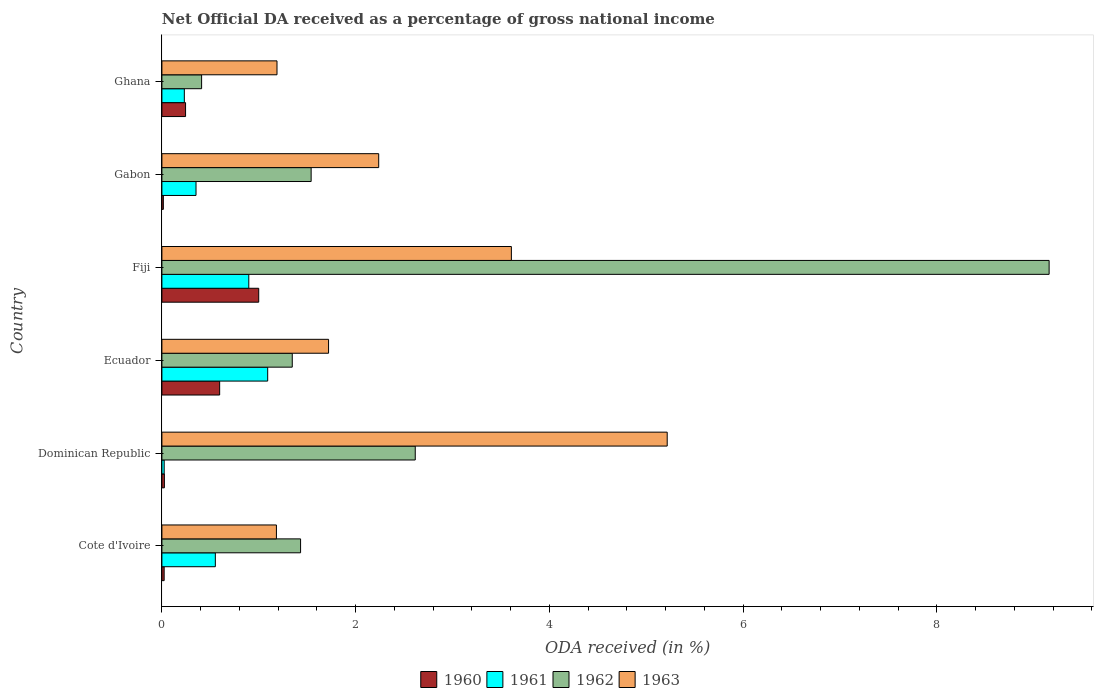How many different coloured bars are there?
Ensure brevity in your answer.  4. Are the number of bars per tick equal to the number of legend labels?
Your response must be concise. Yes. Are the number of bars on each tick of the Y-axis equal?
Keep it short and to the point. Yes. How many bars are there on the 5th tick from the top?
Provide a succinct answer. 4. What is the label of the 3rd group of bars from the top?
Provide a succinct answer. Fiji. In how many cases, is the number of bars for a given country not equal to the number of legend labels?
Offer a terse response. 0. What is the net official DA received in 1960 in Fiji?
Provide a short and direct response. 1. Across all countries, what is the maximum net official DA received in 1960?
Offer a terse response. 1. Across all countries, what is the minimum net official DA received in 1962?
Give a very brief answer. 0.41. In which country was the net official DA received in 1960 maximum?
Give a very brief answer. Fiji. In which country was the net official DA received in 1962 minimum?
Offer a terse response. Ghana. What is the total net official DA received in 1961 in the graph?
Offer a terse response. 3.15. What is the difference between the net official DA received in 1962 in Cote d'Ivoire and that in Ghana?
Give a very brief answer. 1.02. What is the difference between the net official DA received in 1963 in Ghana and the net official DA received in 1960 in Fiji?
Provide a short and direct response. 0.19. What is the average net official DA received in 1962 per country?
Provide a short and direct response. 2.75. What is the difference between the net official DA received in 1960 and net official DA received in 1963 in Ecuador?
Give a very brief answer. -1.12. In how many countries, is the net official DA received in 1963 greater than 3.2 %?
Offer a very short reply. 2. What is the ratio of the net official DA received in 1960 in Fiji to that in Gabon?
Offer a very short reply. 67.36. Is the net official DA received in 1962 in Ecuador less than that in Gabon?
Offer a terse response. Yes. What is the difference between the highest and the second highest net official DA received in 1962?
Offer a terse response. 6.54. What is the difference between the highest and the lowest net official DA received in 1962?
Keep it short and to the point. 8.75. Is the sum of the net official DA received in 1961 in Cote d'Ivoire and Ghana greater than the maximum net official DA received in 1963 across all countries?
Give a very brief answer. No. Is it the case that in every country, the sum of the net official DA received in 1961 and net official DA received in 1960 is greater than the sum of net official DA received in 1962 and net official DA received in 1963?
Keep it short and to the point. No. What does the 3rd bar from the bottom in Dominican Republic represents?
Offer a terse response. 1962. How many bars are there?
Make the answer very short. 24. Are all the bars in the graph horizontal?
Keep it short and to the point. Yes. How many countries are there in the graph?
Keep it short and to the point. 6. What is the difference between two consecutive major ticks on the X-axis?
Provide a succinct answer. 2. Does the graph contain any zero values?
Ensure brevity in your answer.  No. Does the graph contain grids?
Keep it short and to the point. No. Where does the legend appear in the graph?
Ensure brevity in your answer.  Bottom center. How are the legend labels stacked?
Give a very brief answer. Horizontal. What is the title of the graph?
Offer a very short reply. Net Official DA received as a percentage of gross national income. What is the label or title of the X-axis?
Provide a short and direct response. ODA received (in %). What is the label or title of the Y-axis?
Your response must be concise. Country. What is the ODA received (in %) in 1960 in Cote d'Ivoire?
Make the answer very short. 0.02. What is the ODA received (in %) in 1961 in Cote d'Ivoire?
Offer a terse response. 0.55. What is the ODA received (in %) in 1962 in Cote d'Ivoire?
Your answer should be very brief. 1.43. What is the ODA received (in %) in 1963 in Cote d'Ivoire?
Your answer should be compact. 1.18. What is the ODA received (in %) of 1960 in Dominican Republic?
Provide a short and direct response. 0.03. What is the ODA received (in %) in 1961 in Dominican Republic?
Give a very brief answer. 0.02. What is the ODA received (in %) of 1962 in Dominican Republic?
Provide a short and direct response. 2.62. What is the ODA received (in %) of 1963 in Dominican Republic?
Keep it short and to the point. 5.22. What is the ODA received (in %) in 1960 in Ecuador?
Make the answer very short. 0.6. What is the ODA received (in %) of 1961 in Ecuador?
Your answer should be very brief. 1.09. What is the ODA received (in %) of 1962 in Ecuador?
Ensure brevity in your answer.  1.35. What is the ODA received (in %) of 1963 in Ecuador?
Make the answer very short. 1.72. What is the ODA received (in %) in 1960 in Fiji?
Your answer should be compact. 1. What is the ODA received (in %) in 1961 in Fiji?
Offer a terse response. 0.9. What is the ODA received (in %) in 1962 in Fiji?
Offer a terse response. 9.16. What is the ODA received (in %) in 1963 in Fiji?
Ensure brevity in your answer.  3.61. What is the ODA received (in %) in 1960 in Gabon?
Offer a very short reply. 0.01. What is the ODA received (in %) in 1961 in Gabon?
Make the answer very short. 0.35. What is the ODA received (in %) of 1962 in Gabon?
Your answer should be very brief. 1.54. What is the ODA received (in %) of 1963 in Gabon?
Ensure brevity in your answer.  2.24. What is the ODA received (in %) of 1960 in Ghana?
Your answer should be very brief. 0.24. What is the ODA received (in %) of 1961 in Ghana?
Provide a short and direct response. 0.23. What is the ODA received (in %) of 1962 in Ghana?
Provide a short and direct response. 0.41. What is the ODA received (in %) of 1963 in Ghana?
Give a very brief answer. 1.19. Across all countries, what is the maximum ODA received (in %) in 1960?
Offer a very short reply. 1. Across all countries, what is the maximum ODA received (in %) of 1961?
Keep it short and to the point. 1.09. Across all countries, what is the maximum ODA received (in %) of 1962?
Provide a succinct answer. 9.16. Across all countries, what is the maximum ODA received (in %) in 1963?
Your answer should be very brief. 5.22. Across all countries, what is the minimum ODA received (in %) in 1960?
Make the answer very short. 0.01. Across all countries, what is the minimum ODA received (in %) of 1961?
Make the answer very short. 0.02. Across all countries, what is the minimum ODA received (in %) in 1962?
Provide a succinct answer. 0.41. Across all countries, what is the minimum ODA received (in %) of 1963?
Offer a terse response. 1.18. What is the total ODA received (in %) in 1960 in the graph?
Keep it short and to the point. 1.9. What is the total ODA received (in %) of 1961 in the graph?
Offer a very short reply. 3.15. What is the total ODA received (in %) of 1962 in the graph?
Offer a very short reply. 16.5. What is the total ODA received (in %) in 1963 in the graph?
Provide a succinct answer. 15.15. What is the difference between the ODA received (in %) of 1960 in Cote d'Ivoire and that in Dominican Republic?
Provide a short and direct response. -0. What is the difference between the ODA received (in %) in 1961 in Cote d'Ivoire and that in Dominican Republic?
Ensure brevity in your answer.  0.53. What is the difference between the ODA received (in %) of 1962 in Cote d'Ivoire and that in Dominican Republic?
Make the answer very short. -1.18. What is the difference between the ODA received (in %) in 1963 in Cote d'Ivoire and that in Dominican Republic?
Your answer should be very brief. -4.03. What is the difference between the ODA received (in %) in 1960 in Cote d'Ivoire and that in Ecuador?
Offer a terse response. -0.57. What is the difference between the ODA received (in %) of 1961 in Cote d'Ivoire and that in Ecuador?
Keep it short and to the point. -0.54. What is the difference between the ODA received (in %) of 1962 in Cote d'Ivoire and that in Ecuador?
Make the answer very short. 0.09. What is the difference between the ODA received (in %) of 1963 in Cote d'Ivoire and that in Ecuador?
Offer a terse response. -0.54. What is the difference between the ODA received (in %) of 1960 in Cote d'Ivoire and that in Fiji?
Give a very brief answer. -0.98. What is the difference between the ODA received (in %) of 1961 in Cote d'Ivoire and that in Fiji?
Keep it short and to the point. -0.35. What is the difference between the ODA received (in %) of 1962 in Cote d'Ivoire and that in Fiji?
Ensure brevity in your answer.  -7.73. What is the difference between the ODA received (in %) in 1963 in Cote d'Ivoire and that in Fiji?
Make the answer very short. -2.43. What is the difference between the ODA received (in %) in 1960 in Cote d'Ivoire and that in Gabon?
Your answer should be very brief. 0.01. What is the difference between the ODA received (in %) of 1961 in Cote d'Ivoire and that in Gabon?
Your answer should be compact. 0.2. What is the difference between the ODA received (in %) in 1962 in Cote d'Ivoire and that in Gabon?
Offer a terse response. -0.11. What is the difference between the ODA received (in %) of 1963 in Cote d'Ivoire and that in Gabon?
Offer a very short reply. -1.06. What is the difference between the ODA received (in %) in 1960 in Cote d'Ivoire and that in Ghana?
Your answer should be compact. -0.22. What is the difference between the ODA received (in %) in 1961 in Cote d'Ivoire and that in Ghana?
Offer a terse response. 0.32. What is the difference between the ODA received (in %) of 1962 in Cote d'Ivoire and that in Ghana?
Your response must be concise. 1.02. What is the difference between the ODA received (in %) of 1963 in Cote d'Ivoire and that in Ghana?
Your answer should be very brief. -0.01. What is the difference between the ODA received (in %) of 1960 in Dominican Republic and that in Ecuador?
Keep it short and to the point. -0.57. What is the difference between the ODA received (in %) in 1961 in Dominican Republic and that in Ecuador?
Provide a succinct answer. -1.07. What is the difference between the ODA received (in %) of 1962 in Dominican Republic and that in Ecuador?
Provide a succinct answer. 1.27. What is the difference between the ODA received (in %) in 1963 in Dominican Republic and that in Ecuador?
Your answer should be very brief. 3.5. What is the difference between the ODA received (in %) of 1960 in Dominican Republic and that in Fiji?
Make the answer very short. -0.97. What is the difference between the ODA received (in %) of 1961 in Dominican Republic and that in Fiji?
Your response must be concise. -0.87. What is the difference between the ODA received (in %) in 1962 in Dominican Republic and that in Fiji?
Offer a very short reply. -6.54. What is the difference between the ODA received (in %) in 1963 in Dominican Republic and that in Fiji?
Give a very brief answer. 1.61. What is the difference between the ODA received (in %) in 1960 in Dominican Republic and that in Gabon?
Give a very brief answer. 0.01. What is the difference between the ODA received (in %) of 1961 in Dominican Republic and that in Gabon?
Provide a succinct answer. -0.33. What is the difference between the ODA received (in %) in 1962 in Dominican Republic and that in Gabon?
Provide a short and direct response. 1.07. What is the difference between the ODA received (in %) of 1963 in Dominican Republic and that in Gabon?
Your answer should be compact. 2.98. What is the difference between the ODA received (in %) of 1960 in Dominican Republic and that in Ghana?
Ensure brevity in your answer.  -0.22. What is the difference between the ODA received (in %) in 1961 in Dominican Republic and that in Ghana?
Provide a short and direct response. -0.21. What is the difference between the ODA received (in %) in 1962 in Dominican Republic and that in Ghana?
Your response must be concise. 2.21. What is the difference between the ODA received (in %) of 1963 in Dominican Republic and that in Ghana?
Offer a terse response. 4.03. What is the difference between the ODA received (in %) in 1960 in Ecuador and that in Fiji?
Your answer should be very brief. -0.4. What is the difference between the ODA received (in %) of 1961 in Ecuador and that in Fiji?
Offer a terse response. 0.2. What is the difference between the ODA received (in %) of 1962 in Ecuador and that in Fiji?
Provide a succinct answer. -7.81. What is the difference between the ODA received (in %) in 1963 in Ecuador and that in Fiji?
Offer a terse response. -1.89. What is the difference between the ODA received (in %) of 1960 in Ecuador and that in Gabon?
Make the answer very short. 0.58. What is the difference between the ODA received (in %) in 1961 in Ecuador and that in Gabon?
Offer a very short reply. 0.74. What is the difference between the ODA received (in %) in 1962 in Ecuador and that in Gabon?
Give a very brief answer. -0.2. What is the difference between the ODA received (in %) in 1963 in Ecuador and that in Gabon?
Make the answer very short. -0.52. What is the difference between the ODA received (in %) in 1960 in Ecuador and that in Ghana?
Your response must be concise. 0.35. What is the difference between the ODA received (in %) in 1961 in Ecuador and that in Ghana?
Offer a terse response. 0.86. What is the difference between the ODA received (in %) of 1962 in Ecuador and that in Ghana?
Your response must be concise. 0.94. What is the difference between the ODA received (in %) in 1963 in Ecuador and that in Ghana?
Make the answer very short. 0.53. What is the difference between the ODA received (in %) in 1960 in Fiji and that in Gabon?
Your answer should be very brief. 0.98. What is the difference between the ODA received (in %) of 1961 in Fiji and that in Gabon?
Ensure brevity in your answer.  0.55. What is the difference between the ODA received (in %) in 1962 in Fiji and that in Gabon?
Your answer should be very brief. 7.62. What is the difference between the ODA received (in %) of 1963 in Fiji and that in Gabon?
Your answer should be compact. 1.37. What is the difference between the ODA received (in %) of 1960 in Fiji and that in Ghana?
Provide a succinct answer. 0.76. What is the difference between the ODA received (in %) of 1961 in Fiji and that in Ghana?
Your answer should be compact. 0.67. What is the difference between the ODA received (in %) in 1962 in Fiji and that in Ghana?
Keep it short and to the point. 8.75. What is the difference between the ODA received (in %) of 1963 in Fiji and that in Ghana?
Provide a succinct answer. 2.42. What is the difference between the ODA received (in %) in 1960 in Gabon and that in Ghana?
Provide a short and direct response. -0.23. What is the difference between the ODA received (in %) of 1961 in Gabon and that in Ghana?
Offer a very short reply. 0.12. What is the difference between the ODA received (in %) in 1962 in Gabon and that in Ghana?
Keep it short and to the point. 1.13. What is the difference between the ODA received (in %) of 1963 in Gabon and that in Ghana?
Keep it short and to the point. 1.05. What is the difference between the ODA received (in %) in 1960 in Cote d'Ivoire and the ODA received (in %) in 1961 in Dominican Republic?
Keep it short and to the point. -0. What is the difference between the ODA received (in %) in 1960 in Cote d'Ivoire and the ODA received (in %) in 1962 in Dominican Republic?
Provide a succinct answer. -2.59. What is the difference between the ODA received (in %) in 1960 in Cote d'Ivoire and the ODA received (in %) in 1963 in Dominican Republic?
Your answer should be very brief. -5.19. What is the difference between the ODA received (in %) in 1961 in Cote d'Ivoire and the ODA received (in %) in 1962 in Dominican Republic?
Your answer should be compact. -2.06. What is the difference between the ODA received (in %) in 1961 in Cote d'Ivoire and the ODA received (in %) in 1963 in Dominican Republic?
Ensure brevity in your answer.  -4.67. What is the difference between the ODA received (in %) in 1962 in Cote d'Ivoire and the ODA received (in %) in 1963 in Dominican Republic?
Make the answer very short. -3.79. What is the difference between the ODA received (in %) of 1960 in Cote d'Ivoire and the ODA received (in %) of 1961 in Ecuador?
Offer a terse response. -1.07. What is the difference between the ODA received (in %) of 1960 in Cote d'Ivoire and the ODA received (in %) of 1962 in Ecuador?
Provide a succinct answer. -1.32. What is the difference between the ODA received (in %) in 1960 in Cote d'Ivoire and the ODA received (in %) in 1963 in Ecuador?
Provide a succinct answer. -1.7. What is the difference between the ODA received (in %) of 1961 in Cote d'Ivoire and the ODA received (in %) of 1962 in Ecuador?
Provide a succinct answer. -0.79. What is the difference between the ODA received (in %) in 1961 in Cote d'Ivoire and the ODA received (in %) in 1963 in Ecuador?
Give a very brief answer. -1.17. What is the difference between the ODA received (in %) of 1962 in Cote d'Ivoire and the ODA received (in %) of 1963 in Ecuador?
Your response must be concise. -0.29. What is the difference between the ODA received (in %) of 1960 in Cote d'Ivoire and the ODA received (in %) of 1961 in Fiji?
Your response must be concise. -0.87. What is the difference between the ODA received (in %) of 1960 in Cote d'Ivoire and the ODA received (in %) of 1962 in Fiji?
Offer a very short reply. -9.14. What is the difference between the ODA received (in %) in 1960 in Cote d'Ivoire and the ODA received (in %) in 1963 in Fiji?
Provide a succinct answer. -3.58. What is the difference between the ODA received (in %) of 1961 in Cote d'Ivoire and the ODA received (in %) of 1962 in Fiji?
Offer a very short reply. -8.61. What is the difference between the ODA received (in %) in 1961 in Cote d'Ivoire and the ODA received (in %) in 1963 in Fiji?
Provide a succinct answer. -3.06. What is the difference between the ODA received (in %) in 1962 in Cote d'Ivoire and the ODA received (in %) in 1963 in Fiji?
Your answer should be compact. -2.18. What is the difference between the ODA received (in %) in 1960 in Cote d'Ivoire and the ODA received (in %) in 1961 in Gabon?
Your answer should be compact. -0.33. What is the difference between the ODA received (in %) of 1960 in Cote d'Ivoire and the ODA received (in %) of 1962 in Gabon?
Make the answer very short. -1.52. What is the difference between the ODA received (in %) of 1960 in Cote d'Ivoire and the ODA received (in %) of 1963 in Gabon?
Keep it short and to the point. -2.21. What is the difference between the ODA received (in %) of 1961 in Cote d'Ivoire and the ODA received (in %) of 1962 in Gabon?
Provide a short and direct response. -0.99. What is the difference between the ODA received (in %) in 1961 in Cote d'Ivoire and the ODA received (in %) in 1963 in Gabon?
Your answer should be very brief. -1.69. What is the difference between the ODA received (in %) in 1962 in Cote d'Ivoire and the ODA received (in %) in 1963 in Gabon?
Your response must be concise. -0.81. What is the difference between the ODA received (in %) of 1960 in Cote d'Ivoire and the ODA received (in %) of 1961 in Ghana?
Make the answer very short. -0.21. What is the difference between the ODA received (in %) in 1960 in Cote d'Ivoire and the ODA received (in %) in 1962 in Ghana?
Keep it short and to the point. -0.39. What is the difference between the ODA received (in %) in 1960 in Cote d'Ivoire and the ODA received (in %) in 1963 in Ghana?
Offer a very short reply. -1.17. What is the difference between the ODA received (in %) in 1961 in Cote d'Ivoire and the ODA received (in %) in 1962 in Ghana?
Make the answer very short. 0.14. What is the difference between the ODA received (in %) of 1961 in Cote d'Ivoire and the ODA received (in %) of 1963 in Ghana?
Offer a terse response. -0.64. What is the difference between the ODA received (in %) in 1962 in Cote d'Ivoire and the ODA received (in %) in 1963 in Ghana?
Ensure brevity in your answer.  0.24. What is the difference between the ODA received (in %) in 1960 in Dominican Republic and the ODA received (in %) in 1961 in Ecuador?
Offer a terse response. -1.07. What is the difference between the ODA received (in %) in 1960 in Dominican Republic and the ODA received (in %) in 1962 in Ecuador?
Offer a terse response. -1.32. What is the difference between the ODA received (in %) of 1960 in Dominican Republic and the ODA received (in %) of 1963 in Ecuador?
Ensure brevity in your answer.  -1.69. What is the difference between the ODA received (in %) of 1961 in Dominican Republic and the ODA received (in %) of 1962 in Ecuador?
Ensure brevity in your answer.  -1.32. What is the difference between the ODA received (in %) of 1961 in Dominican Republic and the ODA received (in %) of 1963 in Ecuador?
Keep it short and to the point. -1.7. What is the difference between the ODA received (in %) of 1962 in Dominican Republic and the ODA received (in %) of 1963 in Ecuador?
Give a very brief answer. 0.9. What is the difference between the ODA received (in %) of 1960 in Dominican Republic and the ODA received (in %) of 1961 in Fiji?
Offer a very short reply. -0.87. What is the difference between the ODA received (in %) in 1960 in Dominican Republic and the ODA received (in %) in 1962 in Fiji?
Provide a succinct answer. -9.13. What is the difference between the ODA received (in %) of 1960 in Dominican Republic and the ODA received (in %) of 1963 in Fiji?
Your answer should be compact. -3.58. What is the difference between the ODA received (in %) in 1961 in Dominican Republic and the ODA received (in %) in 1962 in Fiji?
Provide a succinct answer. -9.14. What is the difference between the ODA received (in %) of 1961 in Dominican Republic and the ODA received (in %) of 1963 in Fiji?
Offer a very short reply. -3.58. What is the difference between the ODA received (in %) in 1962 in Dominican Republic and the ODA received (in %) in 1963 in Fiji?
Ensure brevity in your answer.  -0.99. What is the difference between the ODA received (in %) of 1960 in Dominican Republic and the ODA received (in %) of 1961 in Gabon?
Offer a very short reply. -0.33. What is the difference between the ODA received (in %) in 1960 in Dominican Republic and the ODA received (in %) in 1962 in Gabon?
Keep it short and to the point. -1.52. What is the difference between the ODA received (in %) of 1960 in Dominican Republic and the ODA received (in %) of 1963 in Gabon?
Provide a succinct answer. -2.21. What is the difference between the ODA received (in %) in 1961 in Dominican Republic and the ODA received (in %) in 1962 in Gabon?
Give a very brief answer. -1.52. What is the difference between the ODA received (in %) of 1961 in Dominican Republic and the ODA received (in %) of 1963 in Gabon?
Your answer should be very brief. -2.21. What is the difference between the ODA received (in %) of 1962 in Dominican Republic and the ODA received (in %) of 1963 in Gabon?
Give a very brief answer. 0.38. What is the difference between the ODA received (in %) in 1960 in Dominican Republic and the ODA received (in %) in 1961 in Ghana?
Ensure brevity in your answer.  -0.21. What is the difference between the ODA received (in %) in 1960 in Dominican Republic and the ODA received (in %) in 1962 in Ghana?
Offer a terse response. -0.38. What is the difference between the ODA received (in %) in 1960 in Dominican Republic and the ODA received (in %) in 1963 in Ghana?
Offer a very short reply. -1.16. What is the difference between the ODA received (in %) of 1961 in Dominican Republic and the ODA received (in %) of 1962 in Ghana?
Your answer should be compact. -0.39. What is the difference between the ODA received (in %) in 1961 in Dominican Republic and the ODA received (in %) in 1963 in Ghana?
Keep it short and to the point. -1.16. What is the difference between the ODA received (in %) of 1962 in Dominican Republic and the ODA received (in %) of 1963 in Ghana?
Your answer should be compact. 1.43. What is the difference between the ODA received (in %) in 1960 in Ecuador and the ODA received (in %) in 1961 in Fiji?
Your response must be concise. -0.3. What is the difference between the ODA received (in %) of 1960 in Ecuador and the ODA received (in %) of 1962 in Fiji?
Keep it short and to the point. -8.56. What is the difference between the ODA received (in %) in 1960 in Ecuador and the ODA received (in %) in 1963 in Fiji?
Provide a short and direct response. -3.01. What is the difference between the ODA received (in %) in 1961 in Ecuador and the ODA received (in %) in 1962 in Fiji?
Keep it short and to the point. -8.07. What is the difference between the ODA received (in %) of 1961 in Ecuador and the ODA received (in %) of 1963 in Fiji?
Make the answer very short. -2.52. What is the difference between the ODA received (in %) of 1962 in Ecuador and the ODA received (in %) of 1963 in Fiji?
Your answer should be very brief. -2.26. What is the difference between the ODA received (in %) in 1960 in Ecuador and the ODA received (in %) in 1961 in Gabon?
Make the answer very short. 0.24. What is the difference between the ODA received (in %) in 1960 in Ecuador and the ODA received (in %) in 1962 in Gabon?
Give a very brief answer. -0.94. What is the difference between the ODA received (in %) of 1960 in Ecuador and the ODA received (in %) of 1963 in Gabon?
Ensure brevity in your answer.  -1.64. What is the difference between the ODA received (in %) of 1961 in Ecuador and the ODA received (in %) of 1962 in Gabon?
Offer a terse response. -0.45. What is the difference between the ODA received (in %) of 1961 in Ecuador and the ODA received (in %) of 1963 in Gabon?
Your answer should be very brief. -1.15. What is the difference between the ODA received (in %) of 1962 in Ecuador and the ODA received (in %) of 1963 in Gabon?
Your answer should be very brief. -0.89. What is the difference between the ODA received (in %) in 1960 in Ecuador and the ODA received (in %) in 1961 in Ghana?
Your response must be concise. 0.36. What is the difference between the ODA received (in %) in 1960 in Ecuador and the ODA received (in %) in 1962 in Ghana?
Give a very brief answer. 0.19. What is the difference between the ODA received (in %) of 1960 in Ecuador and the ODA received (in %) of 1963 in Ghana?
Provide a succinct answer. -0.59. What is the difference between the ODA received (in %) of 1961 in Ecuador and the ODA received (in %) of 1962 in Ghana?
Make the answer very short. 0.68. What is the difference between the ODA received (in %) of 1961 in Ecuador and the ODA received (in %) of 1963 in Ghana?
Your response must be concise. -0.1. What is the difference between the ODA received (in %) of 1962 in Ecuador and the ODA received (in %) of 1963 in Ghana?
Your answer should be compact. 0.16. What is the difference between the ODA received (in %) of 1960 in Fiji and the ODA received (in %) of 1961 in Gabon?
Your response must be concise. 0.65. What is the difference between the ODA received (in %) in 1960 in Fiji and the ODA received (in %) in 1962 in Gabon?
Make the answer very short. -0.54. What is the difference between the ODA received (in %) of 1960 in Fiji and the ODA received (in %) of 1963 in Gabon?
Offer a very short reply. -1.24. What is the difference between the ODA received (in %) of 1961 in Fiji and the ODA received (in %) of 1962 in Gabon?
Offer a terse response. -0.64. What is the difference between the ODA received (in %) in 1961 in Fiji and the ODA received (in %) in 1963 in Gabon?
Provide a short and direct response. -1.34. What is the difference between the ODA received (in %) of 1962 in Fiji and the ODA received (in %) of 1963 in Gabon?
Make the answer very short. 6.92. What is the difference between the ODA received (in %) in 1960 in Fiji and the ODA received (in %) in 1961 in Ghana?
Keep it short and to the point. 0.77. What is the difference between the ODA received (in %) in 1960 in Fiji and the ODA received (in %) in 1962 in Ghana?
Your answer should be very brief. 0.59. What is the difference between the ODA received (in %) of 1960 in Fiji and the ODA received (in %) of 1963 in Ghana?
Ensure brevity in your answer.  -0.19. What is the difference between the ODA received (in %) in 1961 in Fiji and the ODA received (in %) in 1962 in Ghana?
Provide a succinct answer. 0.49. What is the difference between the ODA received (in %) in 1961 in Fiji and the ODA received (in %) in 1963 in Ghana?
Offer a very short reply. -0.29. What is the difference between the ODA received (in %) in 1962 in Fiji and the ODA received (in %) in 1963 in Ghana?
Ensure brevity in your answer.  7.97. What is the difference between the ODA received (in %) in 1960 in Gabon and the ODA received (in %) in 1961 in Ghana?
Give a very brief answer. -0.22. What is the difference between the ODA received (in %) in 1960 in Gabon and the ODA received (in %) in 1962 in Ghana?
Your answer should be compact. -0.4. What is the difference between the ODA received (in %) in 1960 in Gabon and the ODA received (in %) in 1963 in Ghana?
Keep it short and to the point. -1.17. What is the difference between the ODA received (in %) in 1961 in Gabon and the ODA received (in %) in 1962 in Ghana?
Keep it short and to the point. -0.06. What is the difference between the ODA received (in %) in 1961 in Gabon and the ODA received (in %) in 1963 in Ghana?
Make the answer very short. -0.84. What is the difference between the ODA received (in %) of 1962 in Gabon and the ODA received (in %) of 1963 in Ghana?
Ensure brevity in your answer.  0.35. What is the average ODA received (in %) of 1960 per country?
Your answer should be very brief. 0.32. What is the average ODA received (in %) in 1961 per country?
Your answer should be very brief. 0.52. What is the average ODA received (in %) of 1962 per country?
Give a very brief answer. 2.75. What is the average ODA received (in %) in 1963 per country?
Give a very brief answer. 2.53. What is the difference between the ODA received (in %) in 1960 and ODA received (in %) in 1961 in Cote d'Ivoire?
Ensure brevity in your answer.  -0.53. What is the difference between the ODA received (in %) in 1960 and ODA received (in %) in 1962 in Cote d'Ivoire?
Keep it short and to the point. -1.41. What is the difference between the ODA received (in %) in 1960 and ODA received (in %) in 1963 in Cote d'Ivoire?
Your response must be concise. -1.16. What is the difference between the ODA received (in %) in 1961 and ODA received (in %) in 1962 in Cote d'Ivoire?
Make the answer very short. -0.88. What is the difference between the ODA received (in %) in 1961 and ODA received (in %) in 1963 in Cote d'Ivoire?
Ensure brevity in your answer.  -0.63. What is the difference between the ODA received (in %) in 1962 and ODA received (in %) in 1963 in Cote d'Ivoire?
Keep it short and to the point. 0.25. What is the difference between the ODA received (in %) of 1960 and ODA received (in %) of 1961 in Dominican Republic?
Give a very brief answer. 0. What is the difference between the ODA received (in %) in 1960 and ODA received (in %) in 1962 in Dominican Republic?
Keep it short and to the point. -2.59. What is the difference between the ODA received (in %) in 1960 and ODA received (in %) in 1963 in Dominican Republic?
Provide a succinct answer. -5.19. What is the difference between the ODA received (in %) in 1961 and ODA received (in %) in 1962 in Dominican Republic?
Your answer should be very brief. -2.59. What is the difference between the ODA received (in %) of 1961 and ODA received (in %) of 1963 in Dominican Republic?
Provide a short and direct response. -5.19. What is the difference between the ODA received (in %) of 1962 and ODA received (in %) of 1963 in Dominican Republic?
Your answer should be very brief. -2.6. What is the difference between the ODA received (in %) in 1960 and ODA received (in %) in 1961 in Ecuador?
Offer a terse response. -0.5. What is the difference between the ODA received (in %) in 1960 and ODA received (in %) in 1962 in Ecuador?
Offer a very short reply. -0.75. What is the difference between the ODA received (in %) of 1960 and ODA received (in %) of 1963 in Ecuador?
Make the answer very short. -1.12. What is the difference between the ODA received (in %) of 1961 and ODA received (in %) of 1962 in Ecuador?
Offer a terse response. -0.25. What is the difference between the ODA received (in %) of 1961 and ODA received (in %) of 1963 in Ecuador?
Give a very brief answer. -0.63. What is the difference between the ODA received (in %) in 1962 and ODA received (in %) in 1963 in Ecuador?
Your response must be concise. -0.37. What is the difference between the ODA received (in %) of 1960 and ODA received (in %) of 1961 in Fiji?
Provide a succinct answer. 0.1. What is the difference between the ODA received (in %) in 1960 and ODA received (in %) in 1962 in Fiji?
Offer a terse response. -8.16. What is the difference between the ODA received (in %) in 1960 and ODA received (in %) in 1963 in Fiji?
Your answer should be compact. -2.61. What is the difference between the ODA received (in %) in 1961 and ODA received (in %) in 1962 in Fiji?
Give a very brief answer. -8.26. What is the difference between the ODA received (in %) in 1961 and ODA received (in %) in 1963 in Fiji?
Offer a terse response. -2.71. What is the difference between the ODA received (in %) in 1962 and ODA received (in %) in 1963 in Fiji?
Make the answer very short. 5.55. What is the difference between the ODA received (in %) in 1960 and ODA received (in %) in 1961 in Gabon?
Keep it short and to the point. -0.34. What is the difference between the ODA received (in %) of 1960 and ODA received (in %) of 1962 in Gabon?
Your response must be concise. -1.53. What is the difference between the ODA received (in %) in 1960 and ODA received (in %) in 1963 in Gabon?
Your response must be concise. -2.22. What is the difference between the ODA received (in %) in 1961 and ODA received (in %) in 1962 in Gabon?
Make the answer very short. -1.19. What is the difference between the ODA received (in %) in 1961 and ODA received (in %) in 1963 in Gabon?
Offer a very short reply. -1.89. What is the difference between the ODA received (in %) of 1962 and ODA received (in %) of 1963 in Gabon?
Ensure brevity in your answer.  -0.7. What is the difference between the ODA received (in %) of 1960 and ODA received (in %) of 1961 in Ghana?
Ensure brevity in your answer.  0.01. What is the difference between the ODA received (in %) of 1960 and ODA received (in %) of 1962 in Ghana?
Your answer should be very brief. -0.17. What is the difference between the ODA received (in %) in 1960 and ODA received (in %) in 1963 in Ghana?
Keep it short and to the point. -0.94. What is the difference between the ODA received (in %) in 1961 and ODA received (in %) in 1962 in Ghana?
Offer a very short reply. -0.18. What is the difference between the ODA received (in %) of 1961 and ODA received (in %) of 1963 in Ghana?
Give a very brief answer. -0.96. What is the difference between the ODA received (in %) in 1962 and ODA received (in %) in 1963 in Ghana?
Keep it short and to the point. -0.78. What is the ratio of the ODA received (in %) in 1960 in Cote d'Ivoire to that in Dominican Republic?
Your answer should be compact. 0.91. What is the ratio of the ODA received (in %) in 1961 in Cote d'Ivoire to that in Dominican Republic?
Offer a terse response. 23.38. What is the ratio of the ODA received (in %) of 1962 in Cote d'Ivoire to that in Dominican Republic?
Provide a short and direct response. 0.55. What is the ratio of the ODA received (in %) in 1963 in Cote d'Ivoire to that in Dominican Republic?
Your answer should be very brief. 0.23. What is the ratio of the ODA received (in %) in 1960 in Cote d'Ivoire to that in Ecuador?
Make the answer very short. 0.04. What is the ratio of the ODA received (in %) of 1961 in Cote d'Ivoire to that in Ecuador?
Ensure brevity in your answer.  0.51. What is the ratio of the ODA received (in %) in 1962 in Cote d'Ivoire to that in Ecuador?
Give a very brief answer. 1.06. What is the ratio of the ODA received (in %) of 1963 in Cote d'Ivoire to that in Ecuador?
Offer a terse response. 0.69. What is the ratio of the ODA received (in %) of 1960 in Cote d'Ivoire to that in Fiji?
Offer a terse response. 0.02. What is the ratio of the ODA received (in %) in 1961 in Cote d'Ivoire to that in Fiji?
Your response must be concise. 0.61. What is the ratio of the ODA received (in %) of 1962 in Cote d'Ivoire to that in Fiji?
Your answer should be very brief. 0.16. What is the ratio of the ODA received (in %) in 1963 in Cote d'Ivoire to that in Fiji?
Ensure brevity in your answer.  0.33. What is the ratio of the ODA received (in %) in 1960 in Cote d'Ivoire to that in Gabon?
Your answer should be very brief. 1.57. What is the ratio of the ODA received (in %) of 1961 in Cote d'Ivoire to that in Gabon?
Ensure brevity in your answer.  1.57. What is the ratio of the ODA received (in %) of 1962 in Cote d'Ivoire to that in Gabon?
Make the answer very short. 0.93. What is the ratio of the ODA received (in %) in 1963 in Cote d'Ivoire to that in Gabon?
Your answer should be very brief. 0.53. What is the ratio of the ODA received (in %) of 1960 in Cote d'Ivoire to that in Ghana?
Your answer should be very brief. 0.1. What is the ratio of the ODA received (in %) of 1961 in Cote d'Ivoire to that in Ghana?
Provide a short and direct response. 2.38. What is the ratio of the ODA received (in %) in 1962 in Cote d'Ivoire to that in Ghana?
Your answer should be compact. 3.49. What is the ratio of the ODA received (in %) of 1963 in Cote d'Ivoire to that in Ghana?
Offer a terse response. 0.99. What is the ratio of the ODA received (in %) in 1960 in Dominican Republic to that in Ecuador?
Your answer should be compact. 0.04. What is the ratio of the ODA received (in %) in 1961 in Dominican Republic to that in Ecuador?
Ensure brevity in your answer.  0.02. What is the ratio of the ODA received (in %) in 1962 in Dominican Republic to that in Ecuador?
Provide a short and direct response. 1.94. What is the ratio of the ODA received (in %) of 1963 in Dominican Republic to that in Ecuador?
Ensure brevity in your answer.  3.03. What is the ratio of the ODA received (in %) in 1960 in Dominican Republic to that in Fiji?
Ensure brevity in your answer.  0.03. What is the ratio of the ODA received (in %) of 1961 in Dominican Republic to that in Fiji?
Make the answer very short. 0.03. What is the ratio of the ODA received (in %) in 1962 in Dominican Republic to that in Fiji?
Provide a short and direct response. 0.29. What is the ratio of the ODA received (in %) in 1963 in Dominican Republic to that in Fiji?
Provide a short and direct response. 1.45. What is the ratio of the ODA received (in %) in 1960 in Dominican Republic to that in Gabon?
Provide a succinct answer. 1.73. What is the ratio of the ODA received (in %) of 1961 in Dominican Republic to that in Gabon?
Offer a terse response. 0.07. What is the ratio of the ODA received (in %) of 1962 in Dominican Republic to that in Gabon?
Make the answer very short. 1.7. What is the ratio of the ODA received (in %) in 1963 in Dominican Republic to that in Gabon?
Give a very brief answer. 2.33. What is the ratio of the ODA received (in %) of 1960 in Dominican Republic to that in Ghana?
Offer a terse response. 0.1. What is the ratio of the ODA received (in %) in 1961 in Dominican Republic to that in Ghana?
Ensure brevity in your answer.  0.1. What is the ratio of the ODA received (in %) of 1962 in Dominican Republic to that in Ghana?
Offer a very short reply. 6.38. What is the ratio of the ODA received (in %) of 1963 in Dominican Republic to that in Ghana?
Your answer should be compact. 4.39. What is the ratio of the ODA received (in %) in 1960 in Ecuador to that in Fiji?
Offer a very short reply. 0.6. What is the ratio of the ODA received (in %) of 1961 in Ecuador to that in Fiji?
Offer a very short reply. 1.22. What is the ratio of the ODA received (in %) of 1962 in Ecuador to that in Fiji?
Offer a terse response. 0.15. What is the ratio of the ODA received (in %) in 1963 in Ecuador to that in Fiji?
Offer a very short reply. 0.48. What is the ratio of the ODA received (in %) in 1960 in Ecuador to that in Gabon?
Offer a very short reply. 40.19. What is the ratio of the ODA received (in %) of 1961 in Ecuador to that in Gabon?
Your answer should be very brief. 3.1. What is the ratio of the ODA received (in %) of 1962 in Ecuador to that in Gabon?
Your response must be concise. 0.87. What is the ratio of the ODA received (in %) in 1963 in Ecuador to that in Gabon?
Keep it short and to the point. 0.77. What is the ratio of the ODA received (in %) in 1960 in Ecuador to that in Ghana?
Keep it short and to the point. 2.44. What is the ratio of the ODA received (in %) in 1961 in Ecuador to that in Ghana?
Your answer should be compact. 4.72. What is the ratio of the ODA received (in %) in 1962 in Ecuador to that in Ghana?
Your response must be concise. 3.28. What is the ratio of the ODA received (in %) of 1963 in Ecuador to that in Ghana?
Make the answer very short. 1.45. What is the ratio of the ODA received (in %) in 1960 in Fiji to that in Gabon?
Provide a succinct answer. 67.36. What is the ratio of the ODA received (in %) of 1961 in Fiji to that in Gabon?
Give a very brief answer. 2.55. What is the ratio of the ODA received (in %) of 1962 in Fiji to that in Gabon?
Offer a very short reply. 5.94. What is the ratio of the ODA received (in %) in 1963 in Fiji to that in Gabon?
Give a very brief answer. 1.61. What is the ratio of the ODA received (in %) of 1960 in Fiji to that in Ghana?
Make the answer very short. 4.09. What is the ratio of the ODA received (in %) of 1961 in Fiji to that in Ghana?
Offer a terse response. 3.88. What is the ratio of the ODA received (in %) of 1962 in Fiji to that in Ghana?
Make the answer very short. 22.34. What is the ratio of the ODA received (in %) of 1963 in Fiji to that in Ghana?
Your response must be concise. 3.04. What is the ratio of the ODA received (in %) in 1960 in Gabon to that in Ghana?
Provide a short and direct response. 0.06. What is the ratio of the ODA received (in %) of 1961 in Gabon to that in Ghana?
Make the answer very short. 1.52. What is the ratio of the ODA received (in %) in 1962 in Gabon to that in Ghana?
Make the answer very short. 3.76. What is the ratio of the ODA received (in %) of 1963 in Gabon to that in Ghana?
Your response must be concise. 1.88. What is the difference between the highest and the second highest ODA received (in %) of 1960?
Provide a succinct answer. 0.4. What is the difference between the highest and the second highest ODA received (in %) in 1961?
Provide a short and direct response. 0.2. What is the difference between the highest and the second highest ODA received (in %) of 1962?
Make the answer very short. 6.54. What is the difference between the highest and the second highest ODA received (in %) in 1963?
Your response must be concise. 1.61. What is the difference between the highest and the lowest ODA received (in %) in 1960?
Provide a short and direct response. 0.98. What is the difference between the highest and the lowest ODA received (in %) in 1961?
Keep it short and to the point. 1.07. What is the difference between the highest and the lowest ODA received (in %) in 1962?
Keep it short and to the point. 8.75. What is the difference between the highest and the lowest ODA received (in %) of 1963?
Your answer should be very brief. 4.03. 